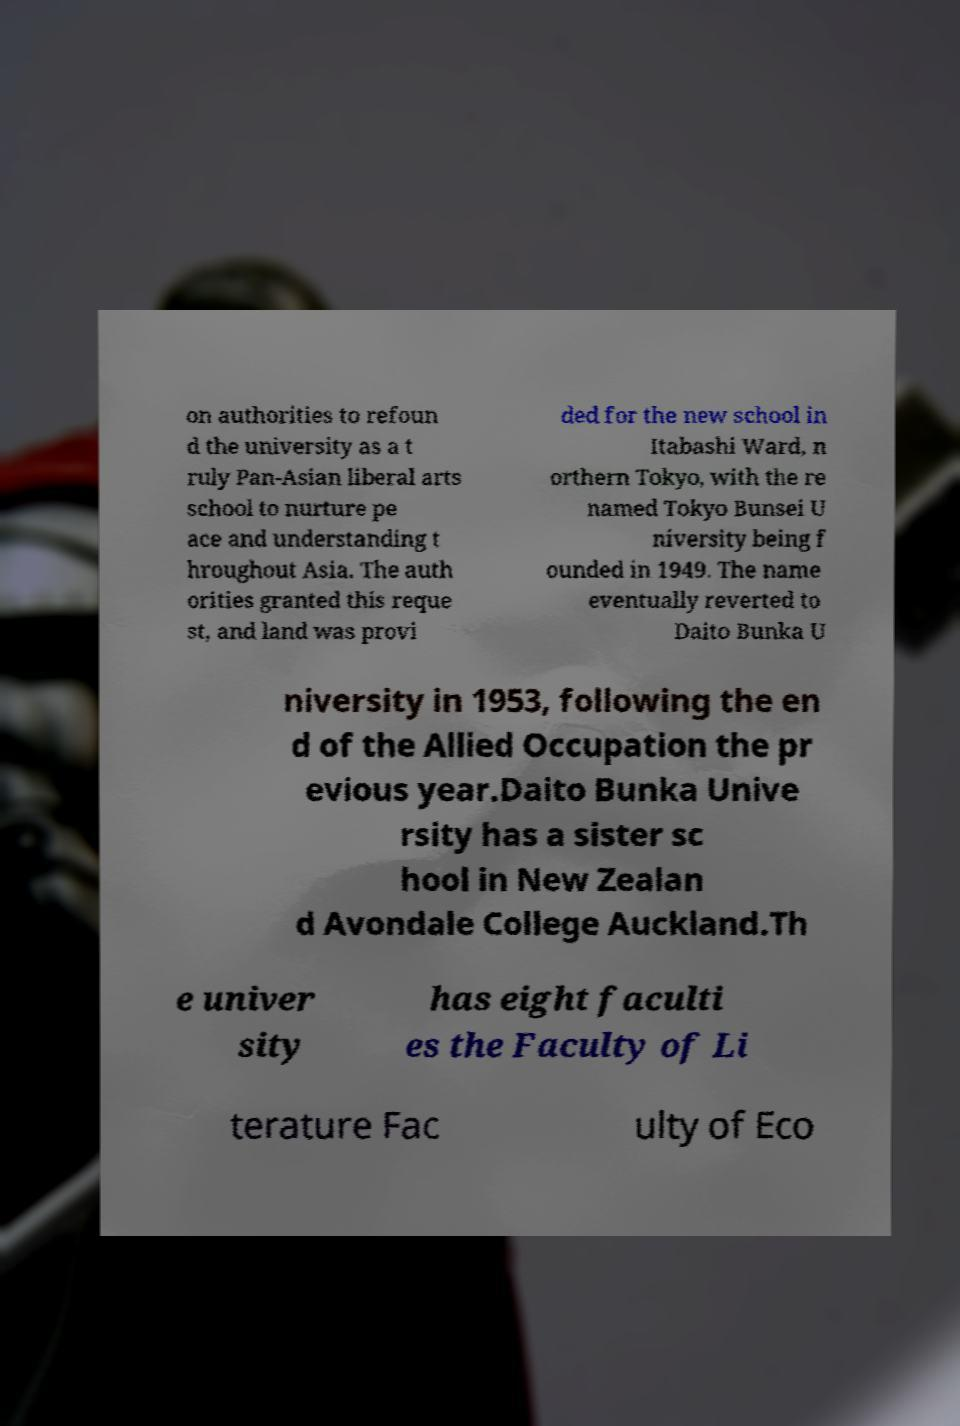I need the written content from this picture converted into text. Can you do that? on authorities to refoun d the university as a t ruly Pan-Asian liberal arts school to nurture pe ace and understanding t hroughout Asia. The auth orities granted this reque st, and land was provi ded for the new school in Itabashi Ward, n orthern Tokyo, with the re named Tokyo Bunsei U niversity being f ounded in 1949. The name eventually reverted to Daito Bunka U niversity in 1953, following the en d of the Allied Occupation the pr evious year.Daito Bunka Unive rsity has a sister sc hool in New Zealan d Avondale College Auckland.Th e univer sity has eight faculti es the Faculty of Li terature Fac ulty of Eco 